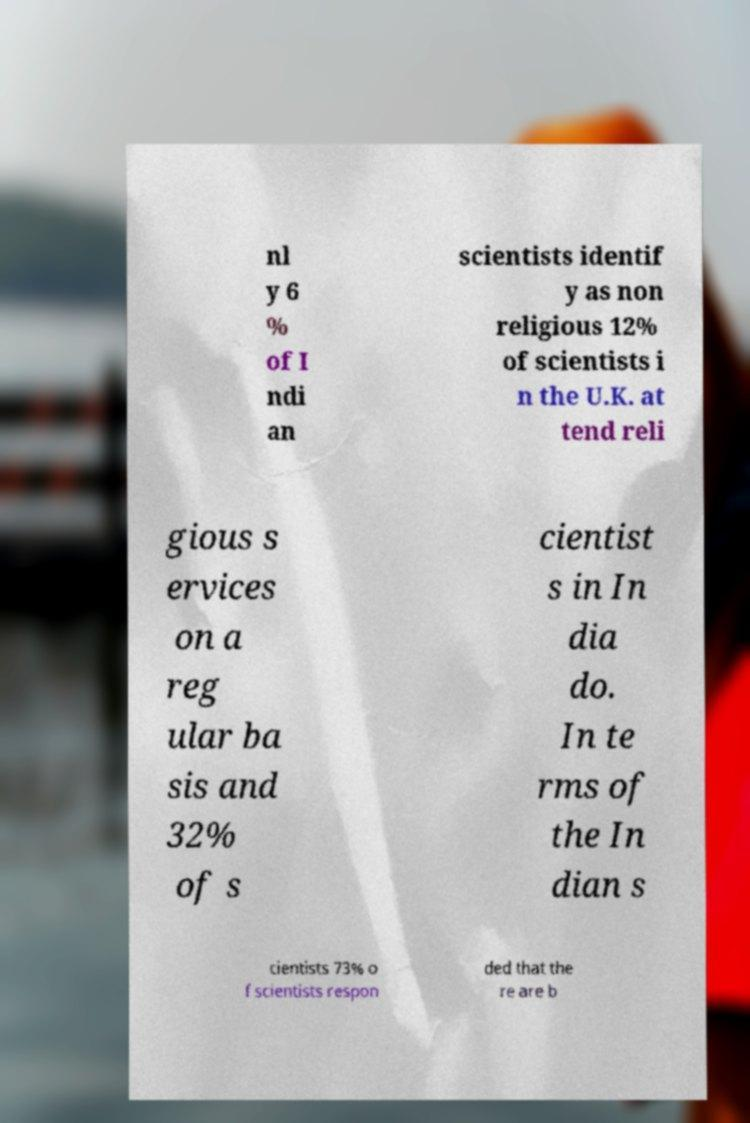Please identify and transcribe the text found in this image. nl y 6 % of I ndi an scientists identif y as non religious 12% of scientists i n the U.K. at tend reli gious s ervices on a reg ular ba sis and 32% of s cientist s in In dia do. In te rms of the In dian s cientists 73% o f scientists respon ded that the re are b 